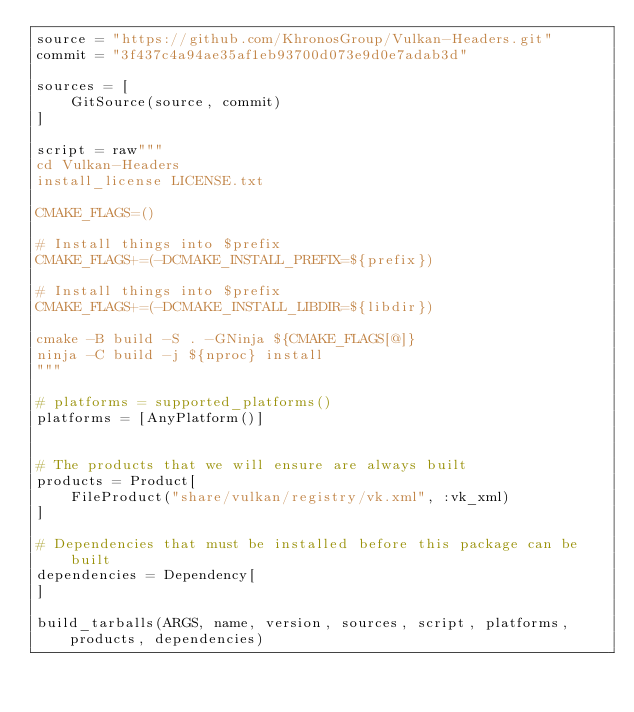<code> <loc_0><loc_0><loc_500><loc_500><_Julia_>source = "https://github.com/KhronosGroup/Vulkan-Headers.git"
commit = "3f437c4a94ae35af1eb93700d073e9d0e7adab3d"

sources = [
    GitSource(source, commit)
]

script = raw"""
cd Vulkan-Headers
install_license LICENSE.txt

CMAKE_FLAGS=()

# Install things into $prefix
CMAKE_FLAGS+=(-DCMAKE_INSTALL_PREFIX=${prefix})

# Install things into $prefix
CMAKE_FLAGS+=(-DCMAKE_INSTALL_LIBDIR=${libdir})

cmake -B build -S . -GNinja ${CMAKE_FLAGS[@]}
ninja -C build -j ${nproc} install
"""

# platforms = supported_platforms()
platforms = [AnyPlatform()]


# The products that we will ensure are always built
products = Product[
    FileProduct("share/vulkan/registry/vk.xml", :vk_xml)
]

# Dependencies that must be installed before this package can be built
dependencies = Dependency[
]

build_tarballs(ARGS, name, version, sources, script, platforms, products, dependencies)
</code> 